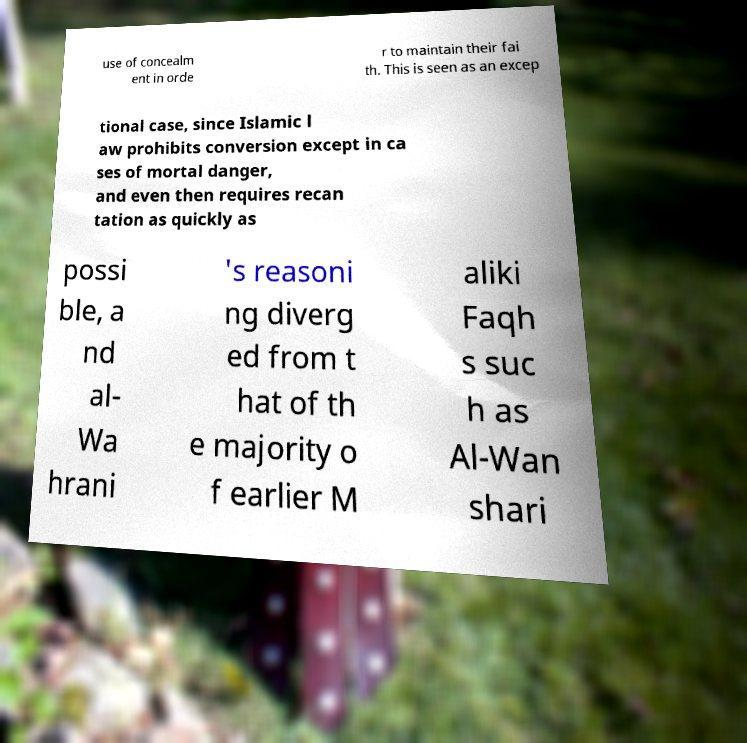For documentation purposes, I need the text within this image transcribed. Could you provide that? use of concealm ent in orde r to maintain their fai th. This is seen as an excep tional case, since Islamic l aw prohibits conversion except in ca ses of mortal danger, and even then requires recan tation as quickly as possi ble, a nd al- Wa hrani 's reasoni ng diverg ed from t hat of th e majority o f earlier M aliki Faqh s suc h as Al-Wan shari 